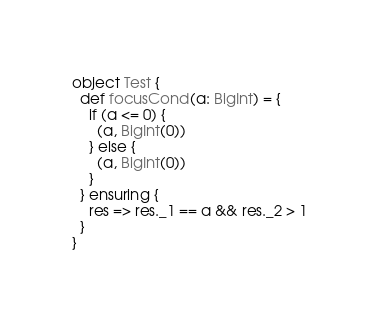Convert code to text. <code><loc_0><loc_0><loc_500><loc_500><_Scala_>object Test {
  def focusCond(a: BigInt) = {
    if (a <= 0) {
      (a, BigInt(0))
    } else {
      (a, BigInt(0))
    }
  } ensuring {
    res => res._1 == a && res._2 > 1
  }
}
</code> 